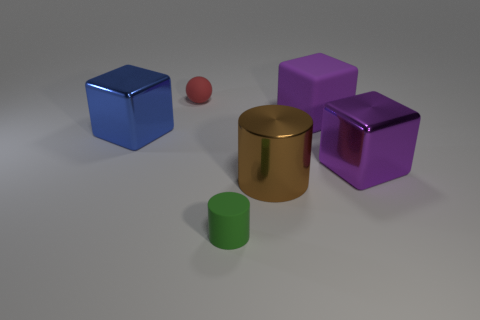Which objects in the image are cubes, and what are their colors? In the image, there are two objects that are shaped as cubes. One is blue and the other is purple. 